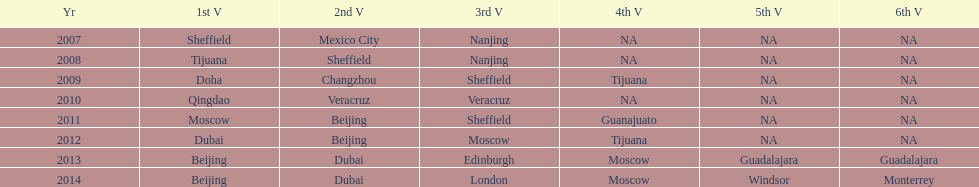In what year was the 3rd venue the same as 2011's 1st venue? 2012. 